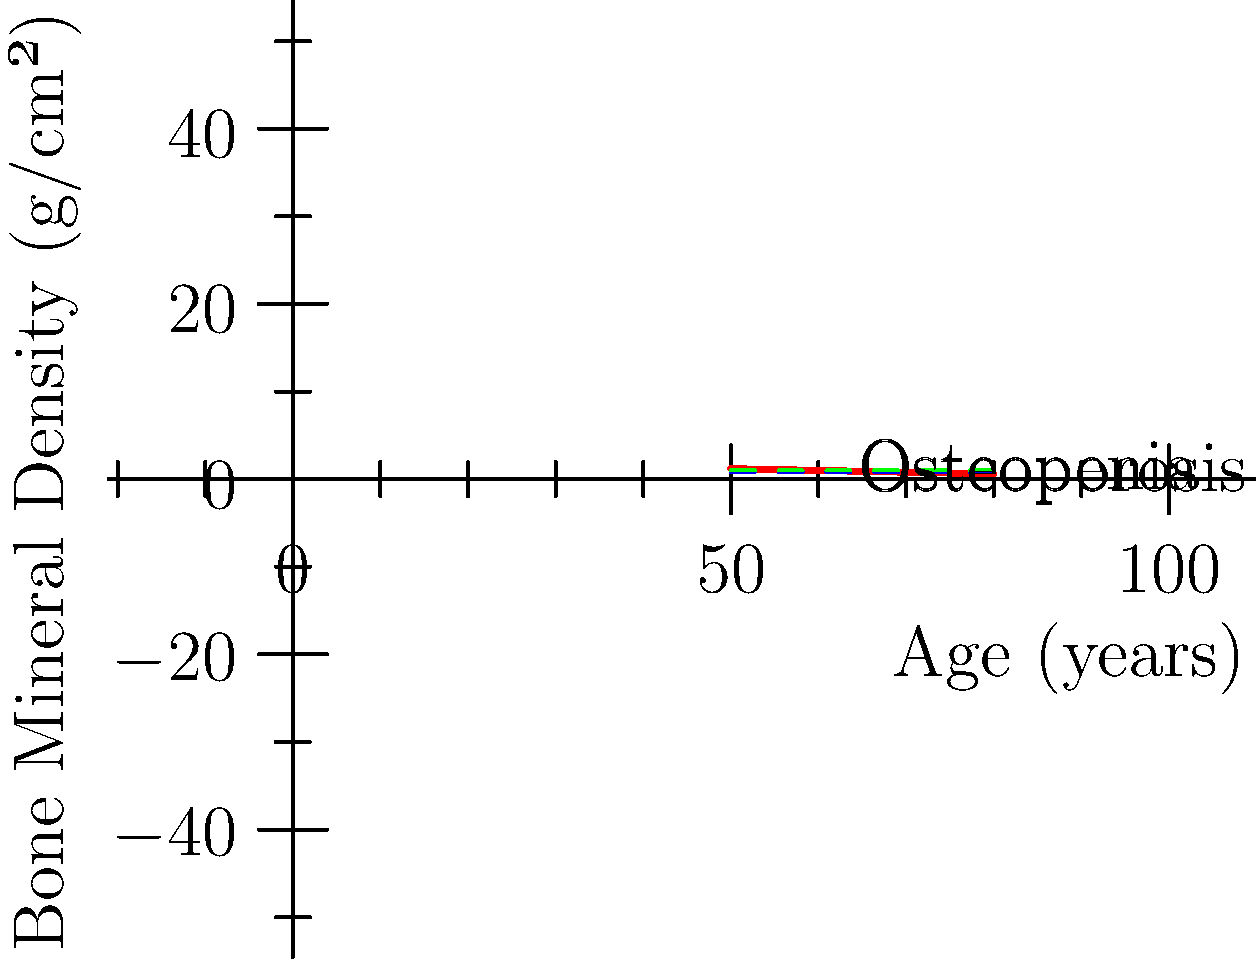Based on the bone density scan results shown in the graph, at what age does the patient's bone mineral density (BMD) cross the threshold for osteoporosis diagnosis (T-score ≤ -2.5 or BMD ≤ 0.8 g/cm²)? How does this relate to the risk of fractures in seniors? To answer this question, we need to follow these steps:

1. Understand the graph:
   - The x-axis represents age in years.
   - The y-axis represents Bone Mineral Density (BMD) in g/cm².
   - The red line shows the patient's BMD trend over time.
   - The blue dashed line at 0.8 g/cm² represents the osteoporosis threshold.

2. Identify the osteoporosis threshold:
   - The osteoporosis threshold is defined as BMD ≤ 0.8 g/cm².

3. Find the intersection point:
   - Locate where the red line (patient's BMD) crosses the blue dashed line (osteoporosis threshold).
   - This occurs at approximately 70 years of age.

4. Interpret the results:
   - The patient's BMD crosses the osteoporosis threshold at age 70.
   - This indicates that the patient is diagnosed with osteoporosis at this age.

5. Relate to fracture risk in seniors:
   - Osteoporosis significantly increases the risk of fractures in seniors.
   - As BMD decreases, bones become more fragile and susceptible to fractures.
   - The World Health Organization (WHO) states that a decrease in BMD by 1 standard deviation increases fracture risk by 1.5 to 3 times.
   - Seniors with osteoporosis are at higher risk for hip, spine, and wrist fractures.
   - Regular monitoring and early intervention are crucial for managing osteoporosis and reducing fracture risk in seniors.
Answer: 70 years; increased fracture risk 